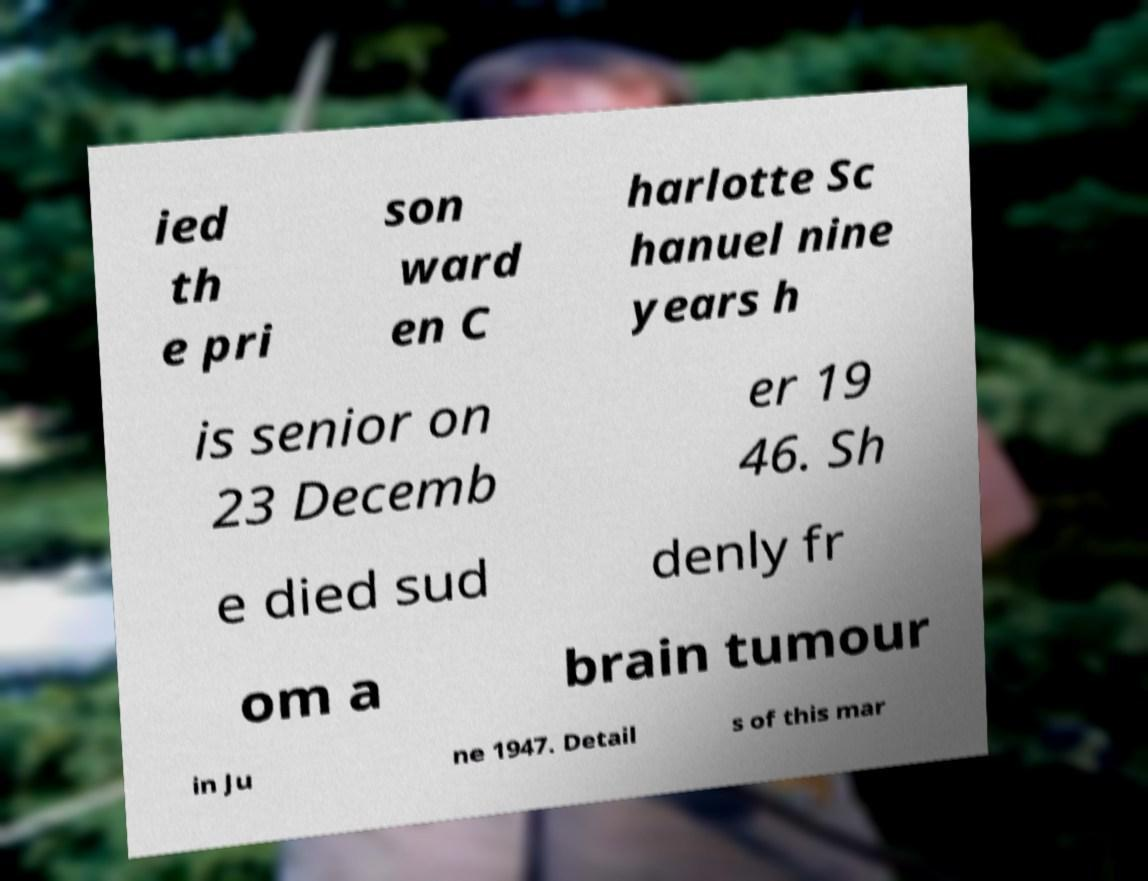For documentation purposes, I need the text within this image transcribed. Could you provide that? ied th e pri son ward en C harlotte Sc hanuel nine years h is senior on 23 Decemb er 19 46. Sh e died sud denly fr om a brain tumour in Ju ne 1947. Detail s of this mar 